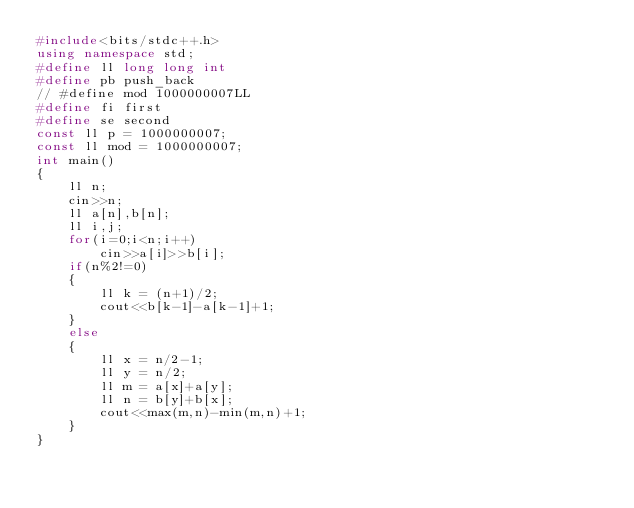<code> <loc_0><loc_0><loc_500><loc_500><_C++_>#include<bits/stdc++.h>
using namespace std;
#define ll long long int
#define pb push_back
// #define mod 1000000007LL
#define fi first
#define se second
const ll p = 1000000007;
const ll mod = 1000000007;
int main()
{
    ll n;
    cin>>n;
    ll a[n],b[n];
    ll i,j;
    for(i=0;i<n;i++)
        cin>>a[i]>>b[i];
    if(n%2!=0)
    {
        ll k = (n+1)/2;
        cout<<b[k-1]-a[k-1]+1;
    }
    else
    {
        ll x = n/2-1;
        ll y = n/2;
        ll m = a[x]+a[y];
        ll n = b[y]+b[x];
        cout<<max(m,n)-min(m,n)+1;
    }
}   
</code> 